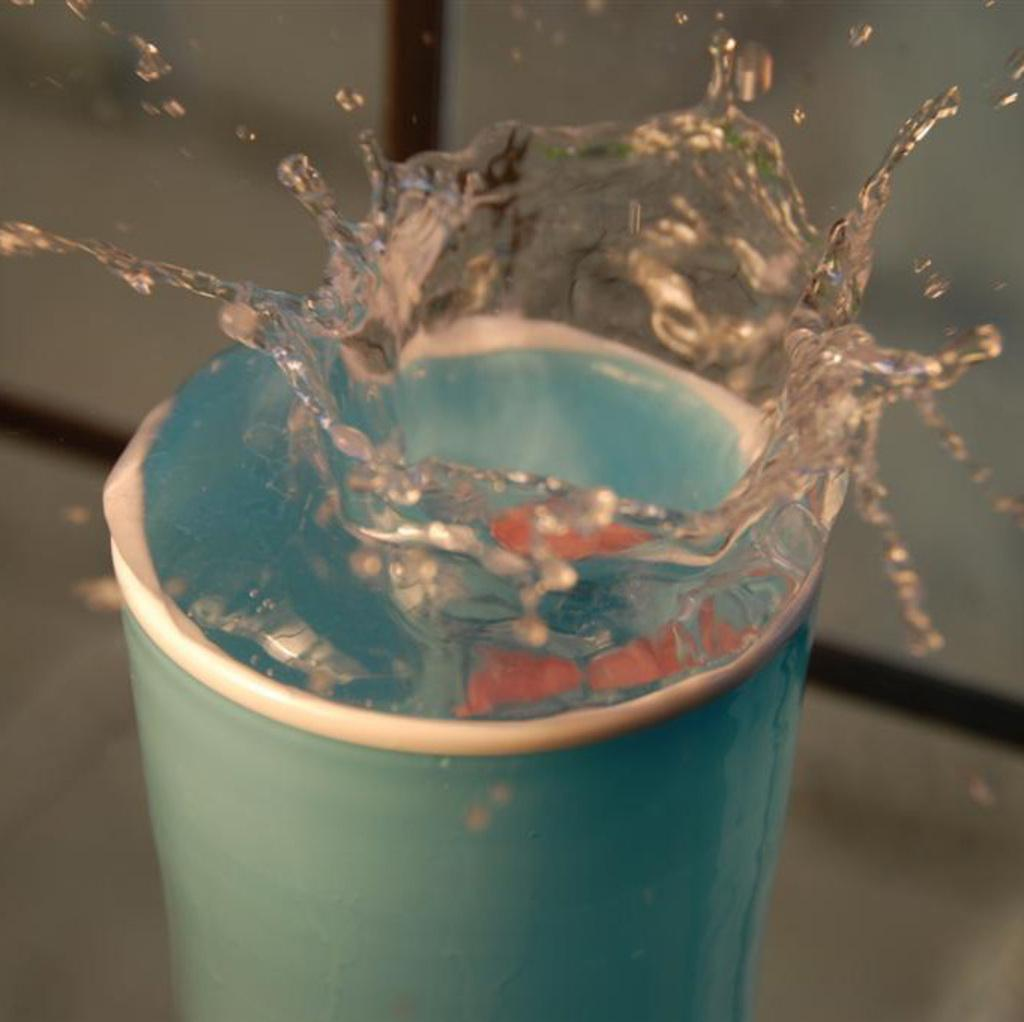What is the color of the glass in the image? The glass in the image is blue. What is inside the glass? There is water in the glass. Can you describe the background of the image? The background of the image is blurred. What condition is the lip of the glass in? There is no lip of the glass visible in the image, so it cannot be determined if it is in any condition. 